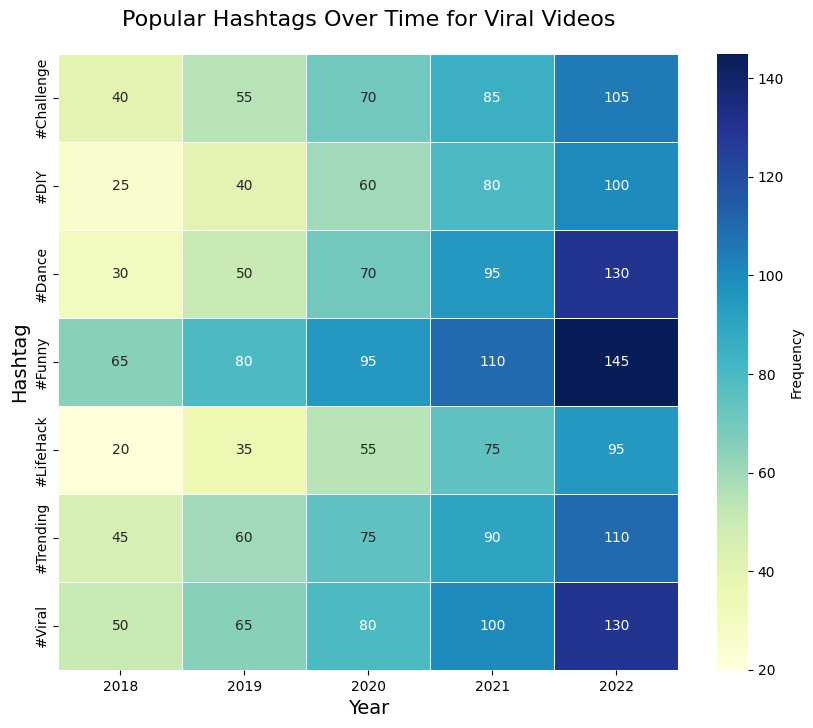What's the frequency of the #Funny hashtag in 2020? Look at the cell where the 2020 column intersects with the #Funny row. The value is 95.
Answer: 95 Which hashtag had the highest frequency in 2021? Compare each value in the 2021 column. The highest value is 110 for the #Funny hashtag.
Answer: #Funny Which year saw the lowest frequency for the #LifeHack hashtag? Look across the #LifeHack row. The lowest value is 20 in 2018.
Answer: 2018 By how much did the frequency of the #Dance hashtag increase from 2018 to 2022? Subtract the 2018 value (30) from the 2022 value (130). The difference is 100.
Answer: 100 What’s the average frequency of the #Challenge hashtag over the five years? Sum the frequencies for #Challenge (40 + 55 + 70 + 85 + 105 = 355) and divide by 5. The average is 71.
Answer: 71 Which year had the most overall hashtag activity? Sum the frequencies for each year and compare. The sums are: 2018 (275), 2019 (385), 2020 (435), 2021 (535), 2022 (715). 2022 has the highest total.
Answer: 2022 Did the frequency of the #Viral hashtag ever exceed 100? If yes, in which year(s)? Check the #Viral row and note the years where the value is greater than 100. The value exceeds 100 in 2021 and 2022.
Answer: 2021 and 2022 Which hashtag experienced the greatest increase in frequency from 2018 to 2022? Calculate the increase for each hashtag: 
#Trending (110-45 = 65), #Viral (130-50 = 80), #Challenge (105-40 = 65), #Funny (145-65 = 80), 
#Dance (130-30 = 100), #LifeHack (95-20 = 75), #DIY (100-25 = 75). 
The greatest increase is for #Dance with 100.
Answer: #Dance By what percentage did the frequency of the #DIY hashtag increase from 2019 to 2022? Calculate the increase from 2019 to 2022 (100 - 40 = 60) and divide by the 2019 value (40). Multiply by 100 to get the percentage (60/40 * 100 = 150%).
Answer: 150% 